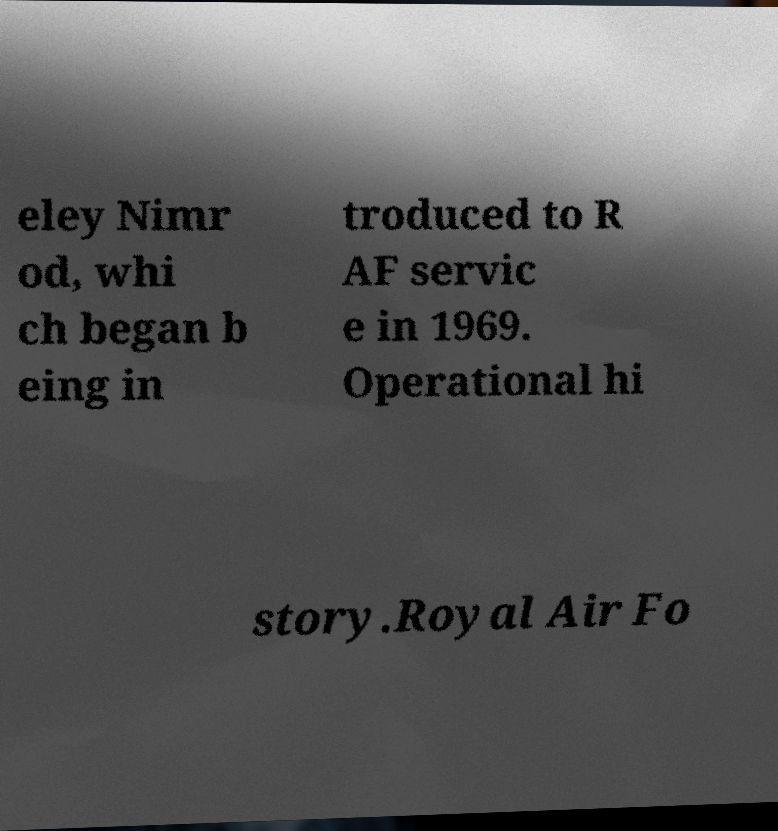I need the written content from this picture converted into text. Can you do that? eley Nimr od, whi ch began b eing in troduced to R AF servic e in 1969. Operational hi story.Royal Air Fo 